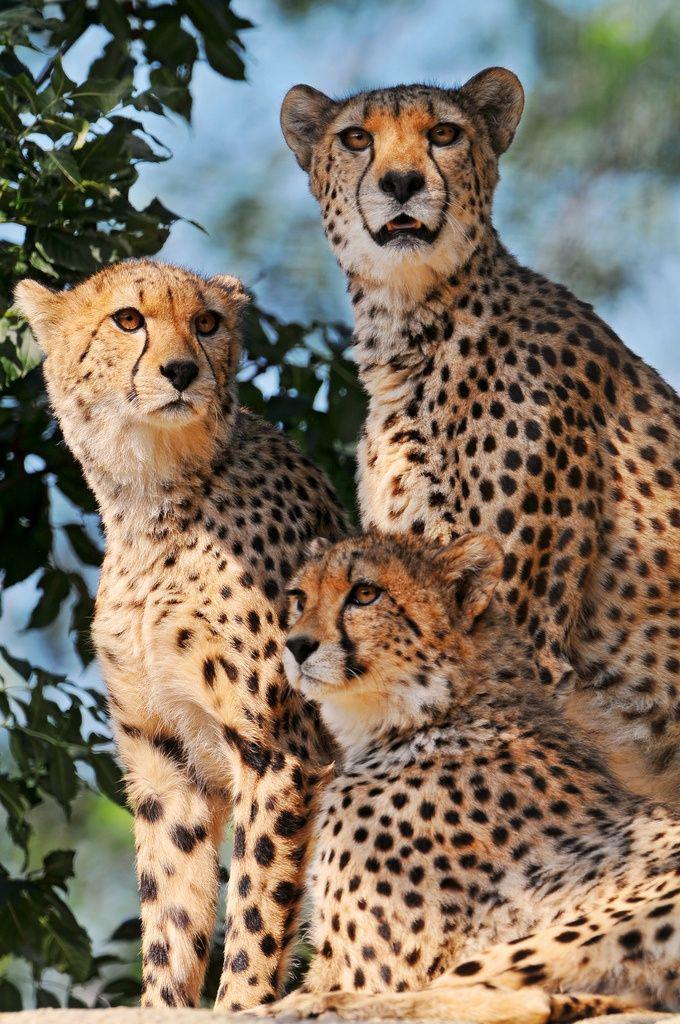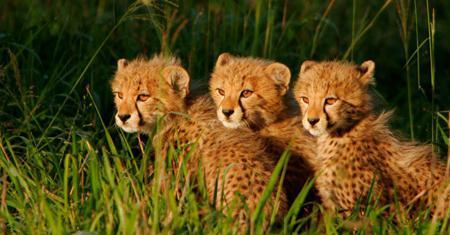The first image is the image on the left, the second image is the image on the right. Considering the images on both sides, is "There are three adult cheetahs in one image and three cheetah cubs in the other image." valid? Answer yes or no. Yes. The first image is the image on the left, the second image is the image on the right. Assess this claim about the two images: "At least two animals are laying down.". Correct or not? Answer yes or no. No. 